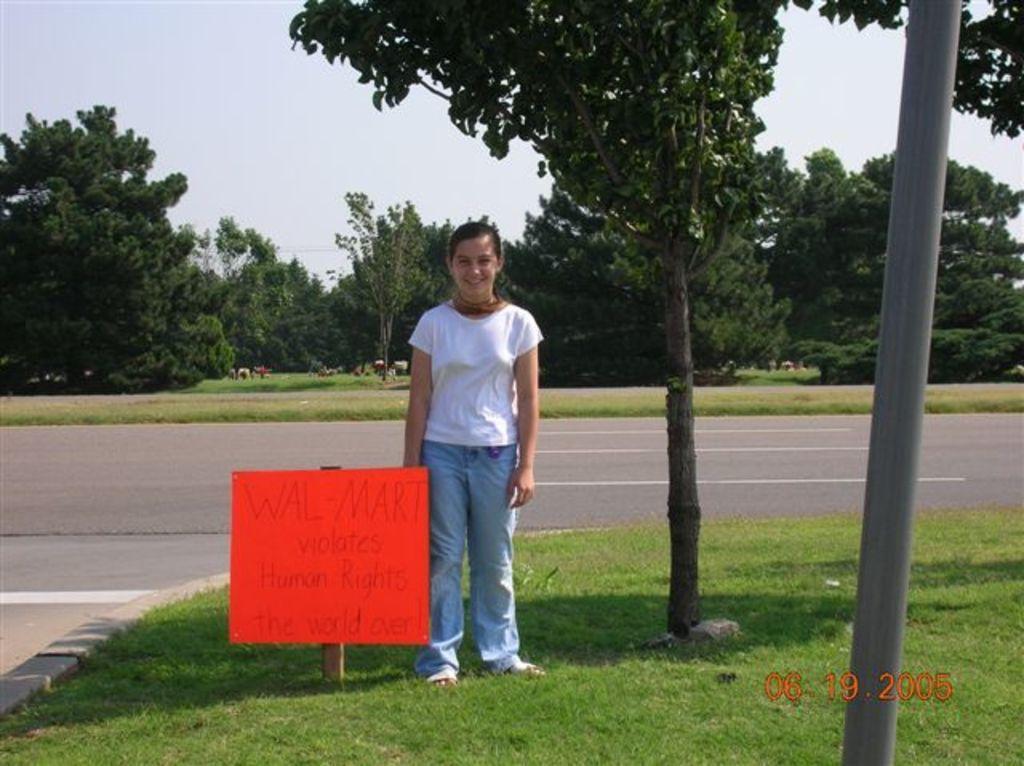Please provide a concise description of this image. In the image there is a girl in white t-shirt and jeans standing beside a ad board on the grassland with trees beside her and beside her there is road with plants and trees in the background and above its sky. 